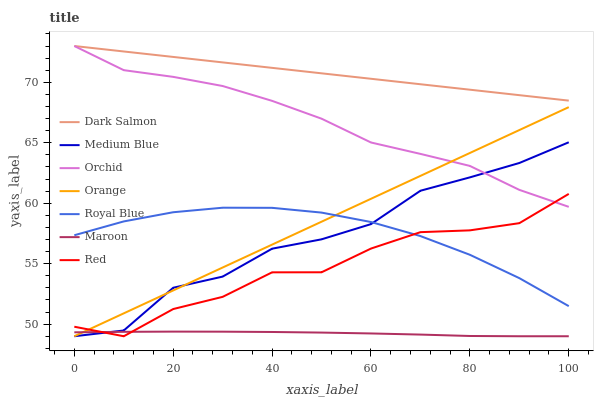Does Dark Salmon have the minimum area under the curve?
Answer yes or no. No. Does Maroon have the maximum area under the curve?
Answer yes or no. No. Is Maroon the smoothest?
Answer yes or no. No. Is Maroon the roughest?
Answer yes or no. No. Does Dark Salmon have the lowest value?
Answer yes or no. No. Does Maroon have the highest value?
Answer yes or no. No. Is Royal Blue less than Orchid?
Answer yes or no. Yes. Is Dark Salmon greater than Royal Blue?
Answer yes or no. Yes. Does Royal Blue intersect Orchid?
Answer yes or no. No. 